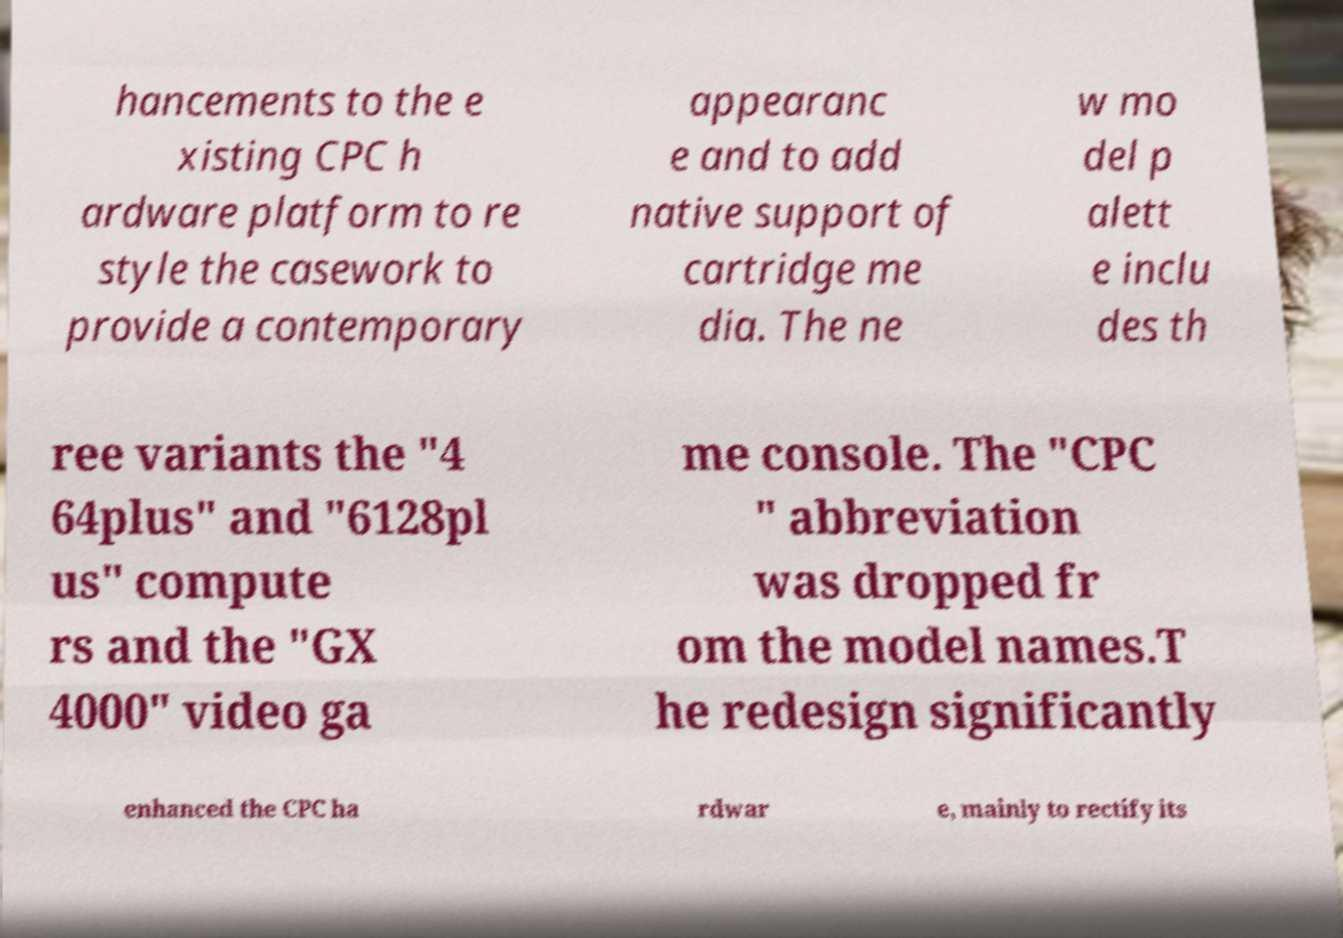What messages or text are displayed in this image? I need them in a readable, typed format. hancements to the e xisting CPC h ardware platform to re style the casework to provide a contemporary appearanc e and to add native support of cartridge me dia. The ne w mo del p alett e inclu des th ree variants the "4 64plus" and "6128pl us" compute rs and the "GX 4000" video ga me console. The "CPC " abbreviation was dropped fr om the model names.T he redesign significantly enhanced the CPC ha rdwar e, mainly to rectify its 